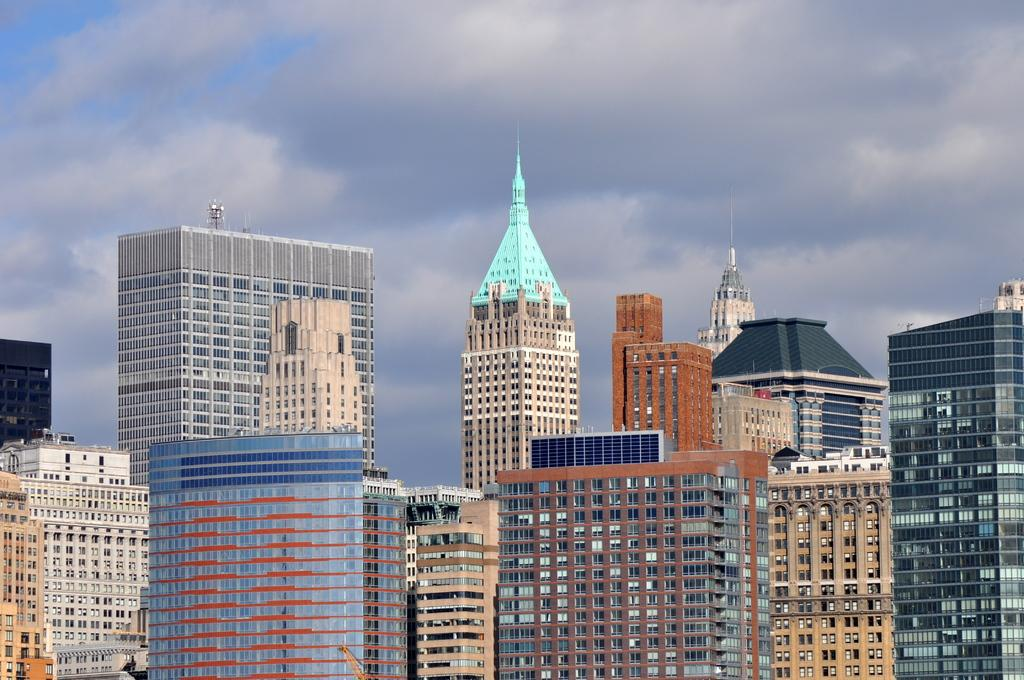What type of structures are present in the image? There are big buildings in the image. What can be seen in the background of the image? The sky is visible in the background of the image. How would you describe the sky in the image? The sky appears to be cloudy. How many sailboats can be seen in the image? There are no sailboats present in the image; it features big buildings and a cloudy sky. What color is the ladybug on the buildings in the image? There is no ladybug present on the buildings in the image. 